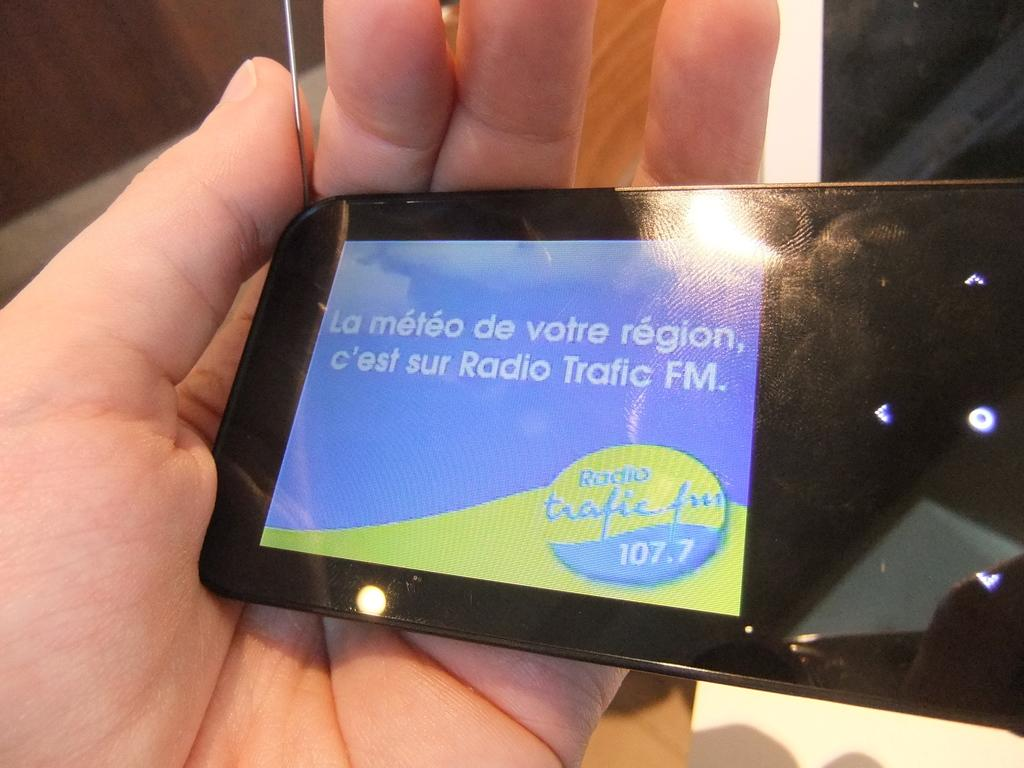<image>
Provide a brief description of the given image. Person holding a device that says 107.7 on it. 